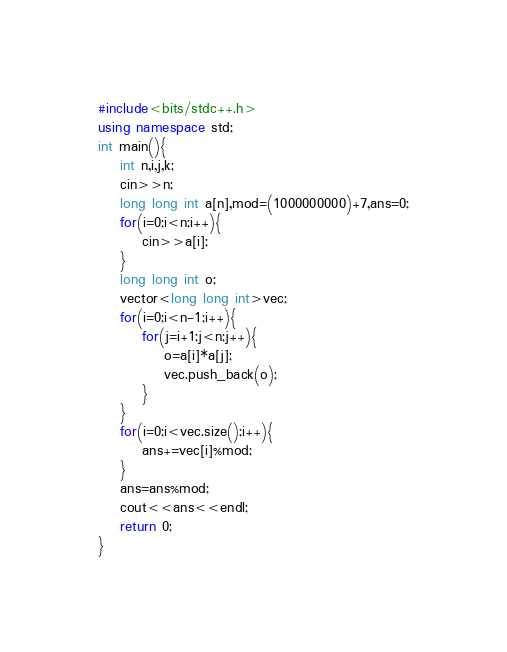Convert code to text. <code><loc_0><loc_0><loc_500><loc_500><_C++_>#include<bits/stdc++.h>
using namespace std;
int main(){
    int n,i,j,k;
    cin>>n;
    long long int a[n],mod=(1000000000)+7,ans=0;
    for(i=0;i<n;i++){
        cin>>a[i];
    }
    long long int o;
    vector<long long int>vec;
    for(i=0;i<n-1;i++){
        for(j=i+1;j<n;j++){
            o=a[i]*a[j];
            vec.push_back(o);
        }
    }
    for(i=0;i<vec.size();i++){
        ans+=vec[i]%mod;
    }
    ans=ans%mod;
    cout<<ans<<endl;
    return 0;
}
</code> 